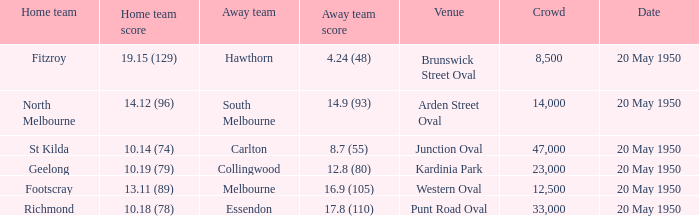What was the largest crowd to view a game where the away team scored 17.8 (110)? 33000.0. 